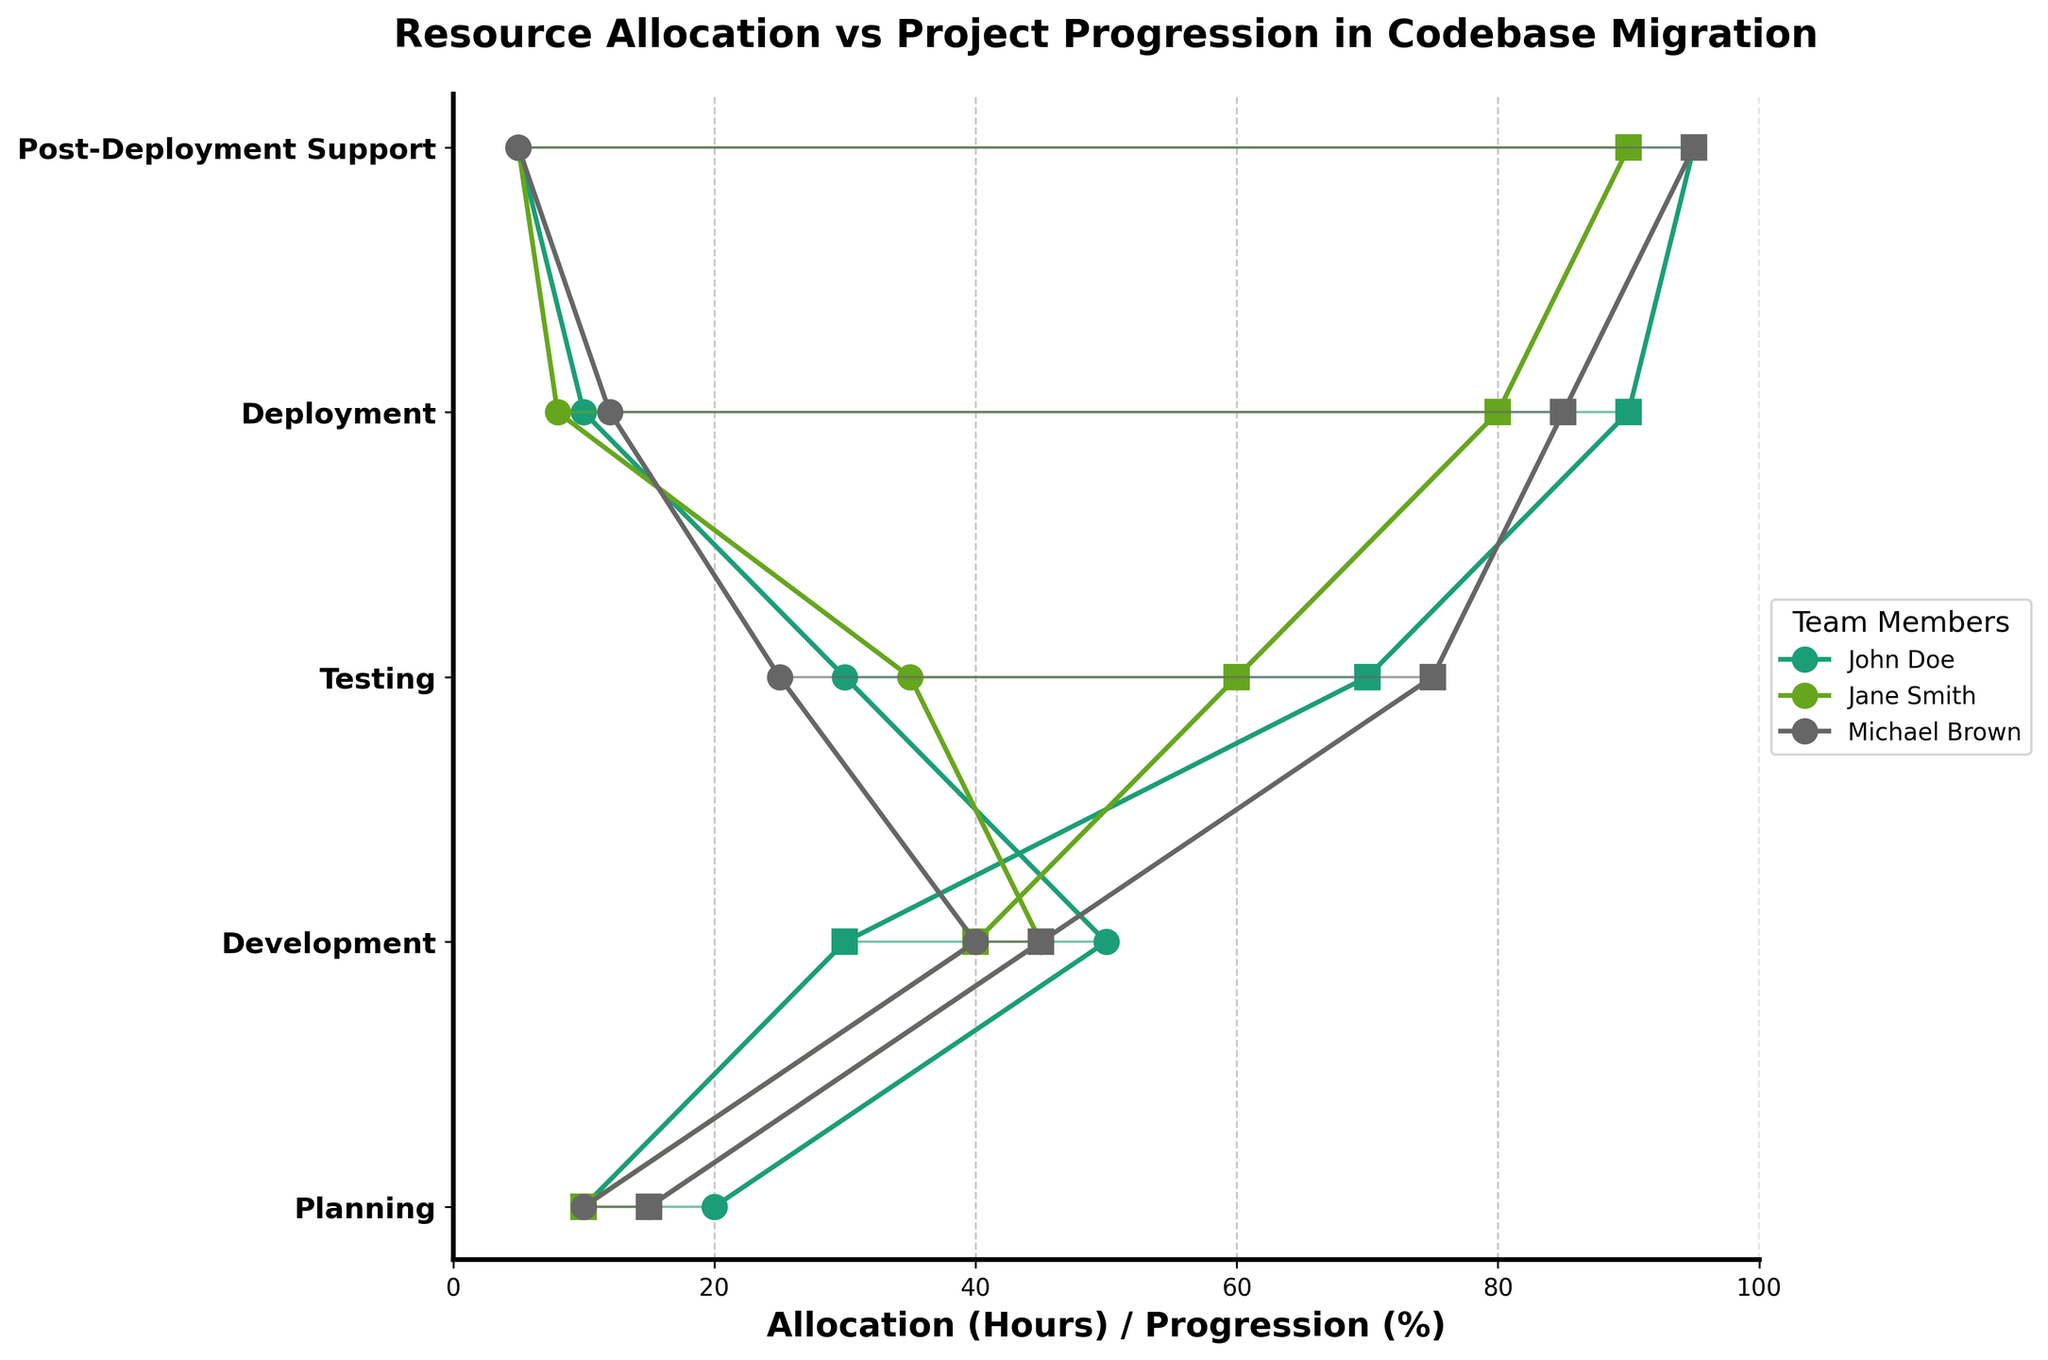What is the title of the plot? The title is usually prominently displayed at the top of the plot. In this case, it's clear from the code provided.
Answer: Resource Allocation vs Project Progression in Codebase Migration Which team member had the highest allocation of hours during the Development phase? Look at the Development phase and compare the hours allocated. John Doe had 50, Jane Smith 45, and Michael Brown 40.
Answer: John Doe What is the difference in project progression (%) between Michael Brown and Jane Smith during the Testing phase? In the Testing phase, Michael Brown has a progression of 75%, and Jane Smith has 60%. The difference is calculated by subtracting 60 from 75.
Answer: 15% Which project phase shows the least amount of progression for John Doe? Review the progression percentages for John Doe across all phases and identify the smallest value. 10% during the Planning phase is the lowest.
Answer: Planning What's the average project progression (%) during the Post-Deployment Support phase across all team members? Summing up the progression percentages in the Post-Deployment Support phase for John Doe (95), Jane Smith (90), and Michael Brown (95). Then, divide by the number of team members (3). (95 + 90+ 95) / 3 = 280 / 3.
Answer: 93.33% For which phase is the spread (difference between allocation and progression) the highest for Jane Smith? Calculate the spread for each phase for Jane Smith: Planning (15-10=5), Development (45-40=5), Testing (35-60=25), Deployment (8-80=72), Post-Deployment Support (5-90=85). The highest spread is in Deployment.
Answer: Deployment Compare the progression (%) of Michael Brown and John Doe during the Deployment phase. Who has higher progression and by how much? Look at the progression percentages during Deployment: Michael Brown (85%) and John Doe (90%). John Doe has higher progression. Subtract Michael Brown’s percentage from John Doe's.
Answer: John Doe by 5% How many phases have team members reached at least 50% progression? Identify phases where at least one team member reached or exceeded 50%. Development (Jane Smith 40%, Michael Brown 45% — not reached), Testing (John Doe 70%, Jane Smith 60%, Michael Brown 75% — reached), Deployment (John Doe 90%, Jane Smith 80%, Michael Brown 85% — reached), Post-Deployment Support (John Doe 95%, Jane Smith 90%, Michael Brown 95% — reached).
Answer: 3 